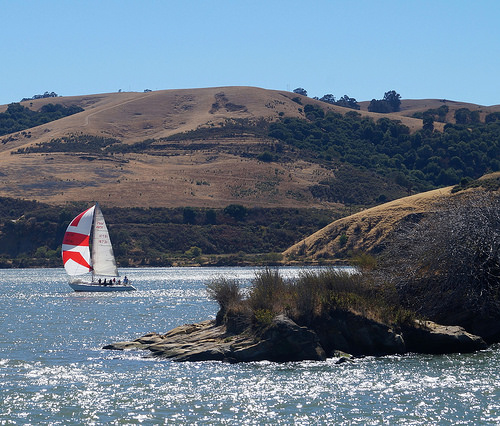<image>
Is there a boat in front of the shore? No. The boat is not in front of the shore. The spatial positioning shows a different relationship between these objects. 